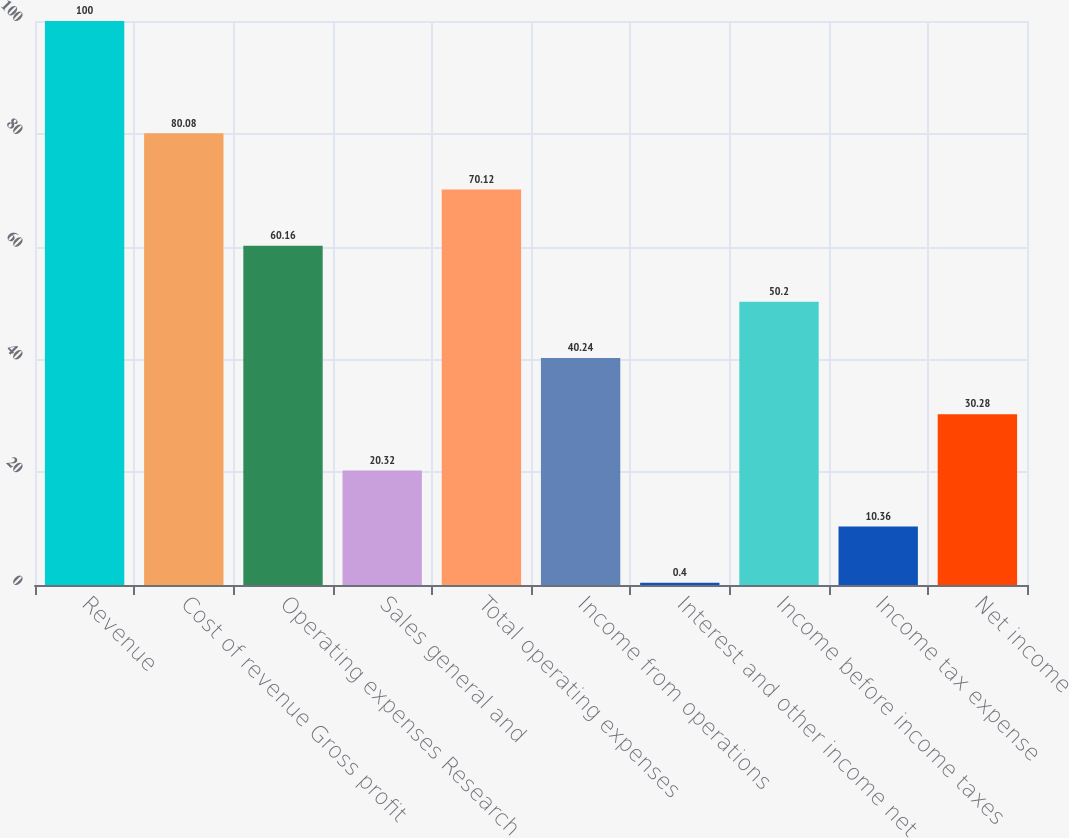<chart> <loc_0><loc_0><loc_500><loc_500><bar_chart><fcel>Revenue<fcel>Cost of revenue Gross profit<fcel>Operating expenses Research<fcel>Sales general and<fcel>Total operating expenses<fcel>Income from operations<fcel>Interest and other income net<fcel>Income before income taxes<fcel>Income tax expense<fcel>Net income<nl><fcel>100<fcel>80.08<fcel>60.16<fcel>20.32<fcel>70.12<fcel>40.24<fcel>0.4<fcel>50.2<fcel>10.36<fcel>30.28<nl></chart> 